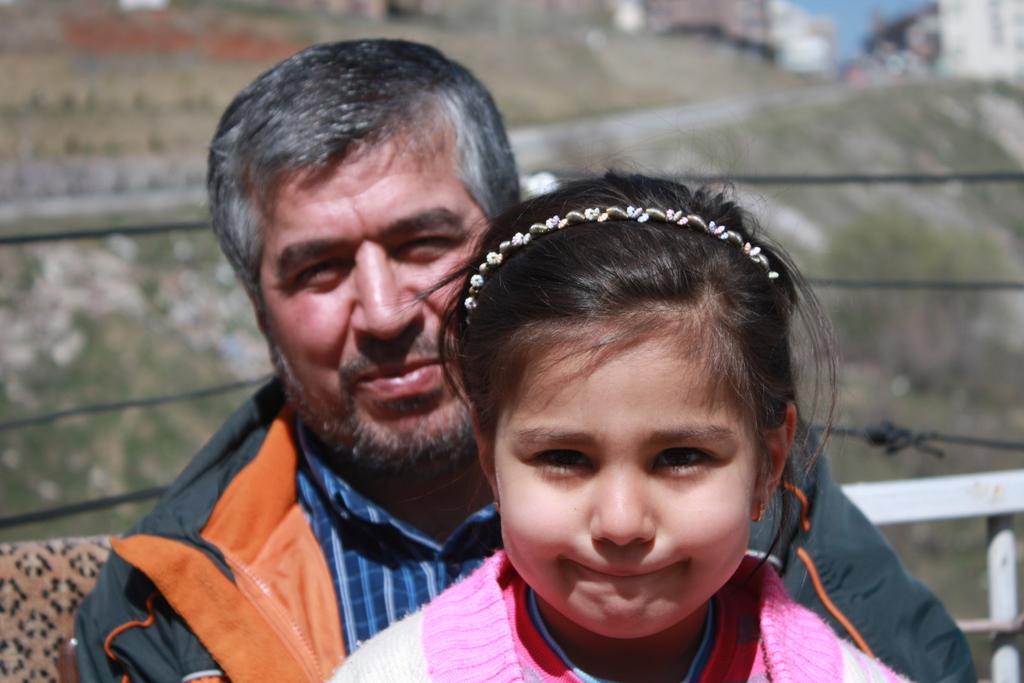How would you summarize this image in a sentence or two? In this picture there is a man who is wearing shirt and jacket. Beside him there is a girl who is wearing pink dress. Both of them are sitting on the chair. On the right there is a steel fencing. In the background i can see the buildings, road and other objects. In the top right there is a sky. 